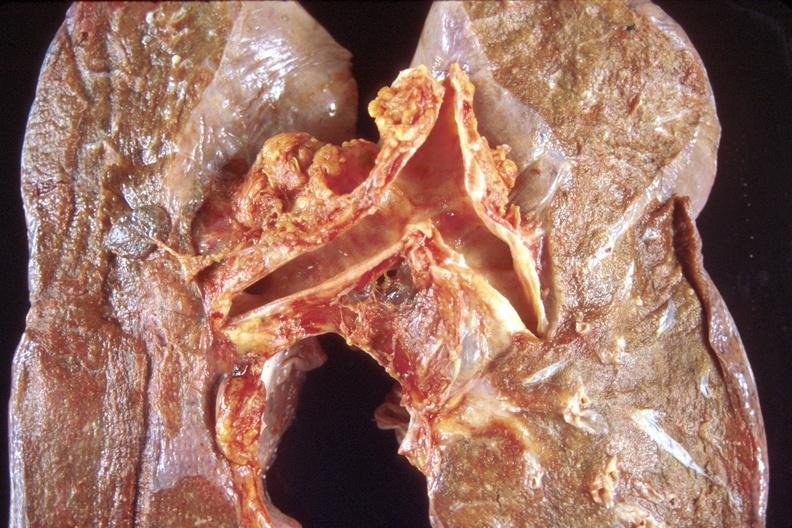does gms show normal lung?
Answer the question using a single word or phrase. No 